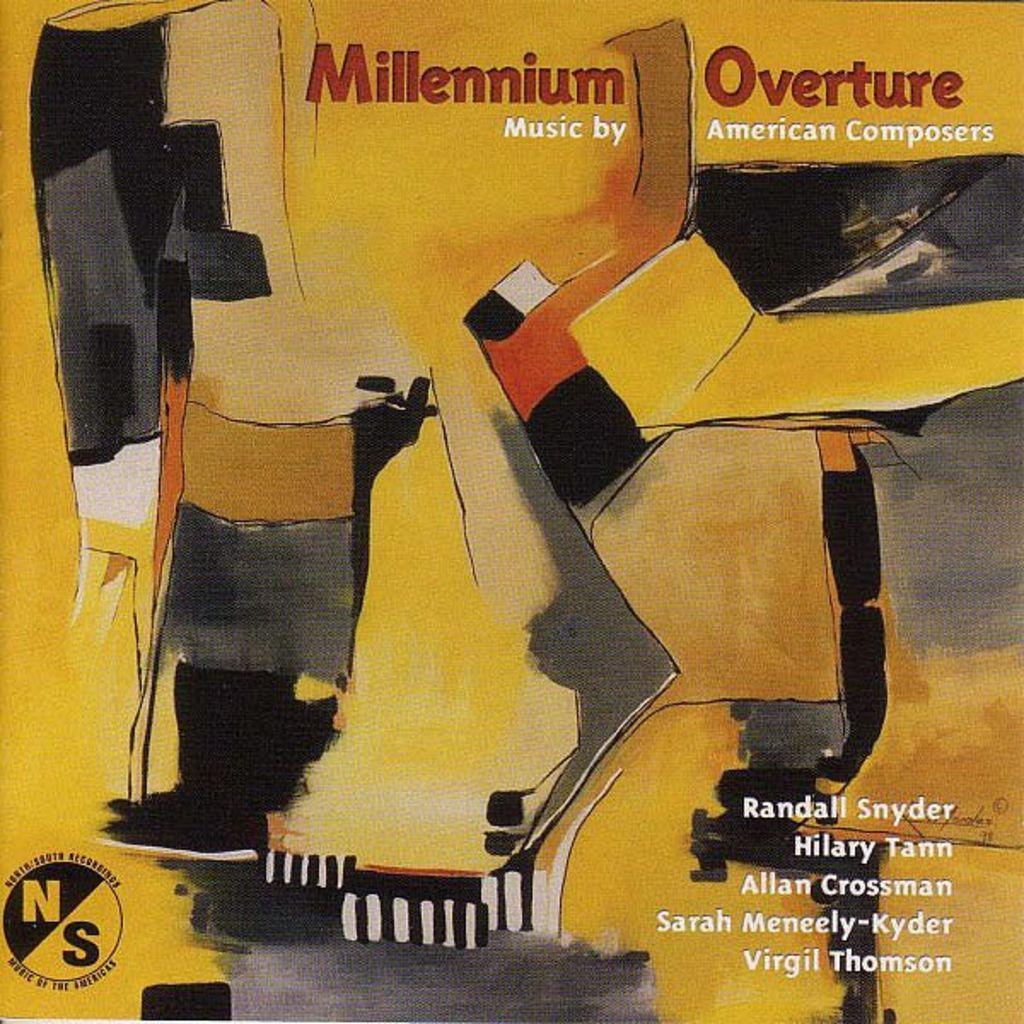<image>
Share a concise interpretation of the image provided. a magazine with Millennium Overture at the top of it 